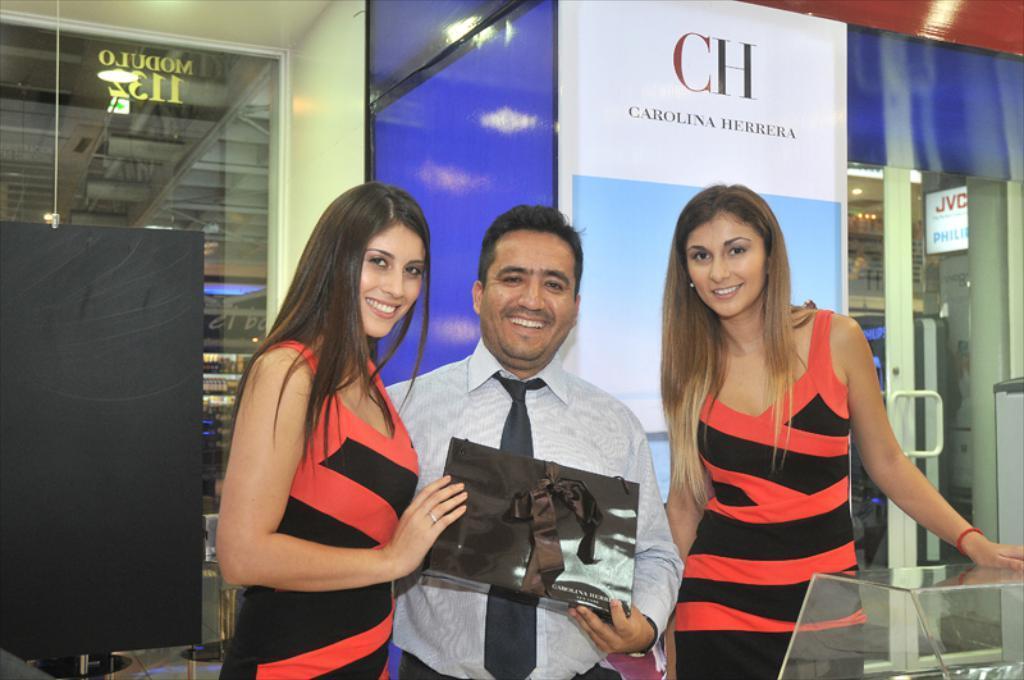Please provide a concise description of this image. In this image there are two women man and woman are holding a box in their hands, in the background there is a glass wall, to that wall there is a banner on that banner there is some text. 